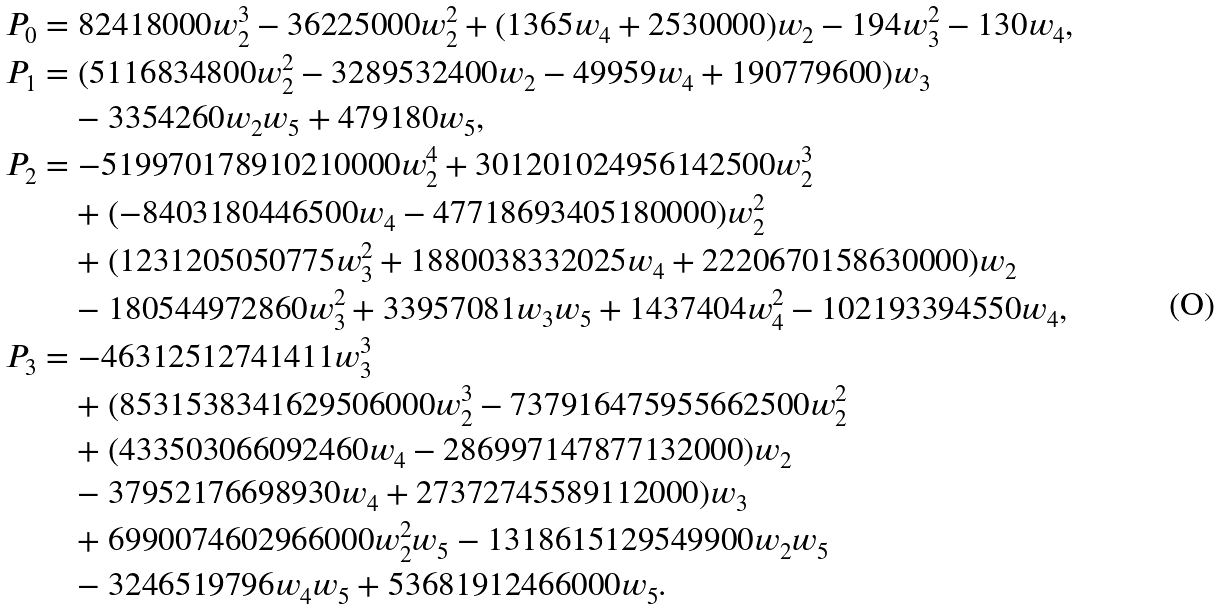<formula> <loc_0><loc_0><loc_500><loc_500>P _ { 0 } & = 8 2 4 1 8 0 0 0 w _ { 2 } ^ { 3 } - 3 6 2 2 5 0 0 0 w _ { 2 } ^ { 2 } + ( 1 3 6 5 w _ { 4 } + 2 5 3 0 0 0 0 ) w _ { 2 } - 1 9 4 w _ { 3 } ^ { 2 } - 1 3 0 w _ { 4 } , \\ P _ { 1 } & = ( 5 1 1 6 8 3 4 8 0 0 w _ { 2 } ^ { 2 } - 3 2 8 9 5 3 2 4 0 0 w _ { 2 } - 4 9 9 5 9 w _ { 4 } + 1 9 0 7 7 9 6 0 0 ) w _ { 3 } \\ & \quad - 3 3 5 4 2 6 0 w _ { 2 } w _ { 5 } + 4 7 9 1 8 0 w _ { 5 } , \\ P _ { 2 } & = - 5 1 9 9 7 0 1 7 8 9 1 0 2 1 0 0 0 0 w _ { 2 } ^ { 4 } + 3 0 1 2 0 1 0 2 4 9 5 6 1 4 2 5 0 0 w _ { 2 } ^ { 3 } \\ & \quad + ( - 8 4 0 3 1 8 0 4 4 6 5 0 0 w _ { 4 } - 4 7 7 1 8 6 9 3 4 0 5 1 8 0 0 0 0 ) w _ { 2 } ^ { 2 } \\ & \quad + ( 1 2 3 1 2 0 5 0 5 0 7 7 5 w _ { 3 } ^ { 2 } + 1 8 8 0 0 3 8 3 3 2 0 2 5 w _ { 4 } + 2 2 2 0 6 7 0 1 5 8 6 3 0 0 0 0 ) w _ { 2 } \\ & \quad - 1 8 0 5 4 4 9 7 2 8 6 0 w _ { 3 } ^ { 2 } + 3 3 9 5 7 0 8 1 w _ { 3 } w _ { 5 } + 1 4 3 7 4 0 4 w _ { 4 } ^ { 2 } - 1 0 2 1 9 3 3 9 4 5 5 0 w _ { 4 } , \\ P _ { 3 } & = - 4 6 3 1 2 5 1 2 7 4 1 4 1 1 w _ { 3 } ^ { 3 } \\ & \quad + ( 8 5 3 1 5 3 8 3 4 1 6 2 9 5 0 6 0 0 0 w _ { 2 } ^ { 3 } - 7 3 7 9 1 6 4 7 5 9 5 5 6 6 2 5 0 0 w _ { 2 } ^ { 2 } \\ & \quad + ( 4 3 3 5 0 3 0 6 6 0 9 2 4 6 0 w _ { 4 } - 2 8 6 9 9 7 1 4 7 8 7 7 1 3 2 0 0 0 ) w _ { 2 } \\ & \quad - 3 7 9 5 2 1 7 6 6 9 8 9 3 0 w _ { 4 } + 2 7 3 7 2 7 4 5 5 8 9 1 1 2 0 0 0 ) w _ { 3 } \\ & \quad + 6 9 9 0 0 7 4 6 0 2 9 6 6 0 0 0 w _ { 2 } ^ { 2 } w _ { 5 } - 1 3 1 8 6 1 5 1 2 9 5 4 9 9 0 0 w _ { 2 } w _ { 5 } \\ & \quad - 3 2 4 6 5 1 9 7 9 6 w _ { 4 } w _ { 5 } + 5 3 6 8 1 9 1 2 4 6 6 0 0 0 w _ { 5 } .</formula> 